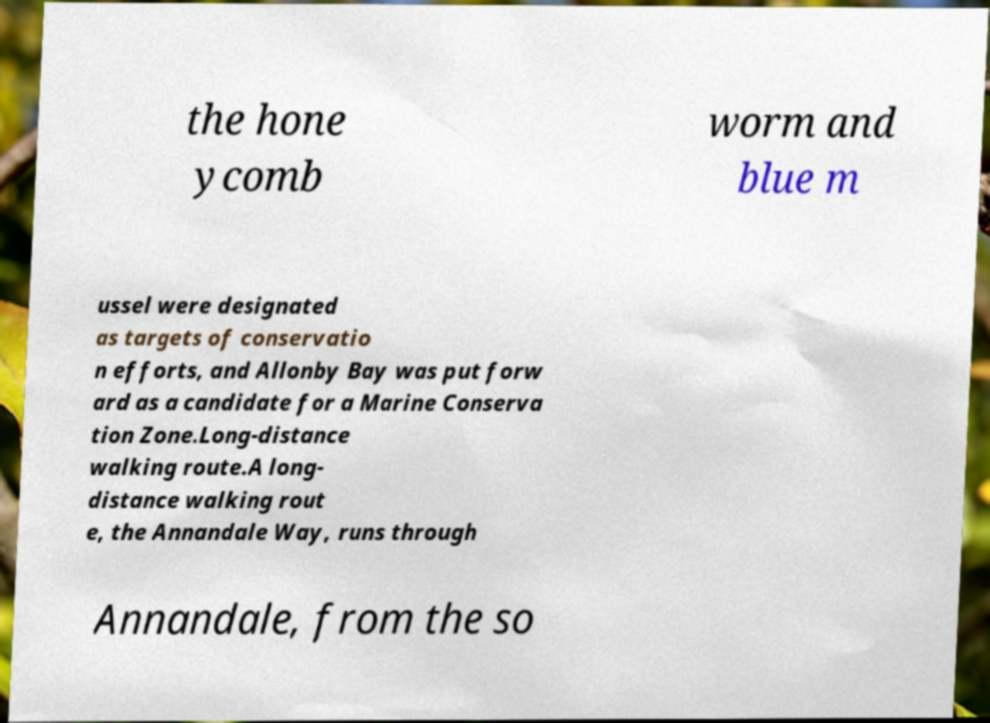Could you assist in decoding the text presented in this image and type it out clearly? the hone ycomb worm and blue m ussel were designated as targets of conservatio n efforts, and Allonby Bay was put forw ard as a candidate for a Marine Conserva tion Zone.Long-distance walking route.A long- distance walking rout e, the Annandale Way, runs through Annandale, from the so 